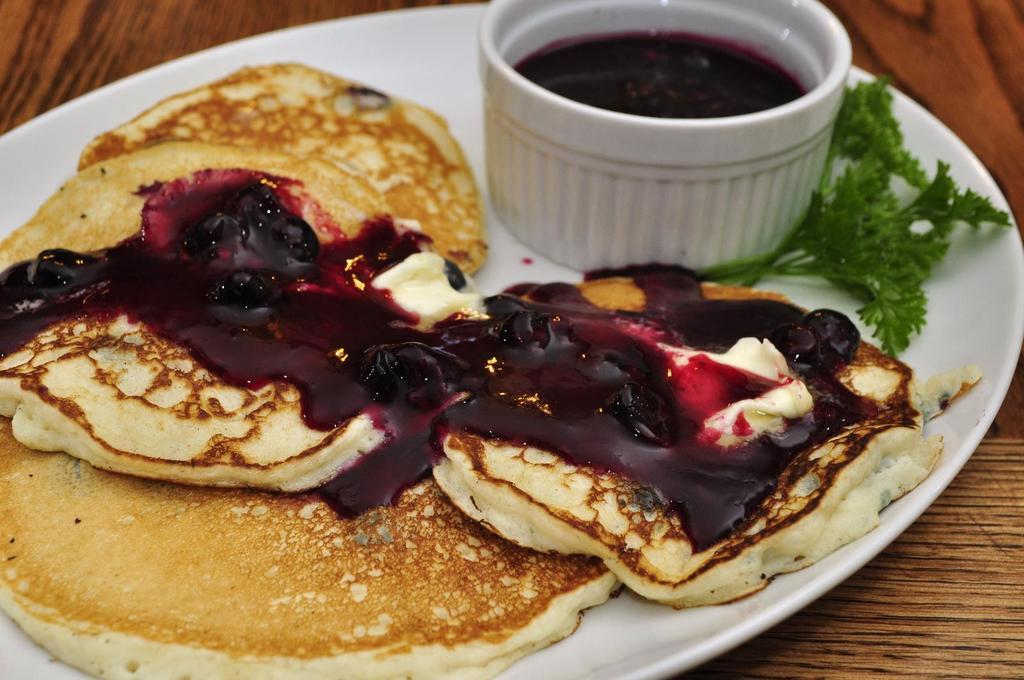What is located in the center of the image? There is a plate in the center of the image. What is the purpose of the plate in the image? The plate contains food items. Can you describe the arrangement of the food items on the plate? There is a bowl in the plate, which suggests that the food items are arranged around the bowl. What type of book is placed next to the plate in the image? There is no book present in the image; it only contains a plate with food items and a bowl. How many cats can be seen interacting with the food items on the plate? There are no cats present in the image; it only contains a plate with food items and a bowl. 